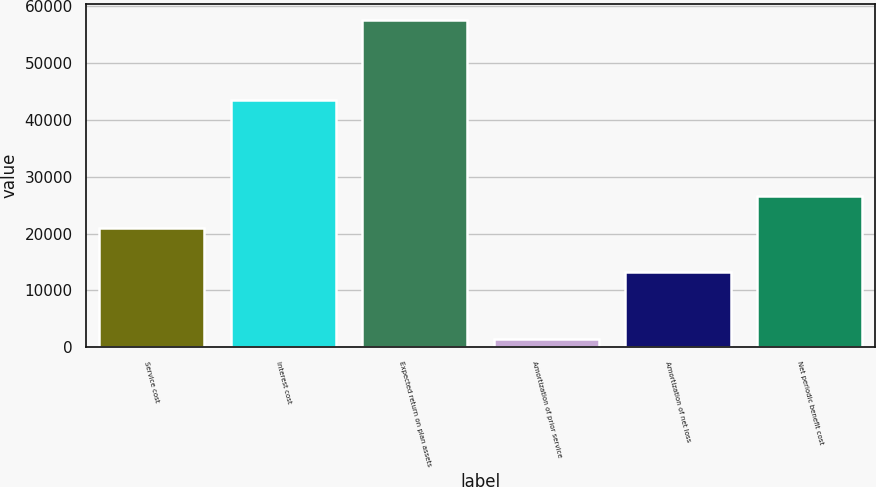Convert chart. <chart><loc_0><loc_0><loc_500><loc_500><bar_chart><fcel>Service cost<fcel>Interest cost<fcel>Expected return on plan assets<fcel>Amortization of prior service<fcel>Amortization of net loss<fcel>Net periodic benefit cost<nl><fcel>20980<fcel>43425<fcel>57586<fcel>1511<fcel>13314<fcel>26587.5<nl></chart> 